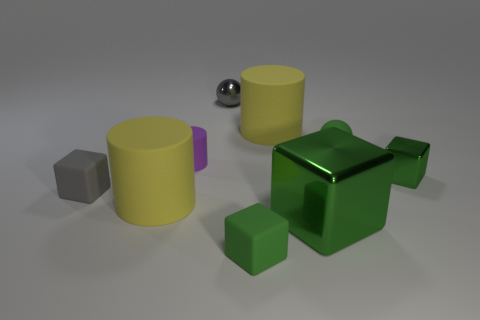How many other things are the same shape as the gray matte object?
Your answer should be compact. 3. What color is the metallic thing that is the same size as the gray sphere?
Your response must be concise. Green. Is the number of yellow matte objects behind the gray metallic ball the same as the number of big metal objects?
Make the answer very short. No. There is a tiny rubber object that is behind the small green shiny object and on the left side of the small rubber ball; what is its shape?
Provide a succinct answer. Cylinder. Is the purple cylinder the same size as the rubber sphere?
Make the answer very short. Yes. Is there a small gray block made of the same material as the small green ball?
Your answer should be very brief. Yes. There is another metal thing that is the same color as the large metallic thing; what size is it?
Provide a succinct answer. Small. How many metal things are in front of the tiny green sphere and on the left side of the tiny green rubber ball?
Your answer should be compact. 1. There is a large yellow cylinder that is to the right of the small metallic ball; what is it made of?
Give a very brief answer. Rubber. What number of big cylinders have the same color as the big metallic cube?
Your answer should be compact. 0. 